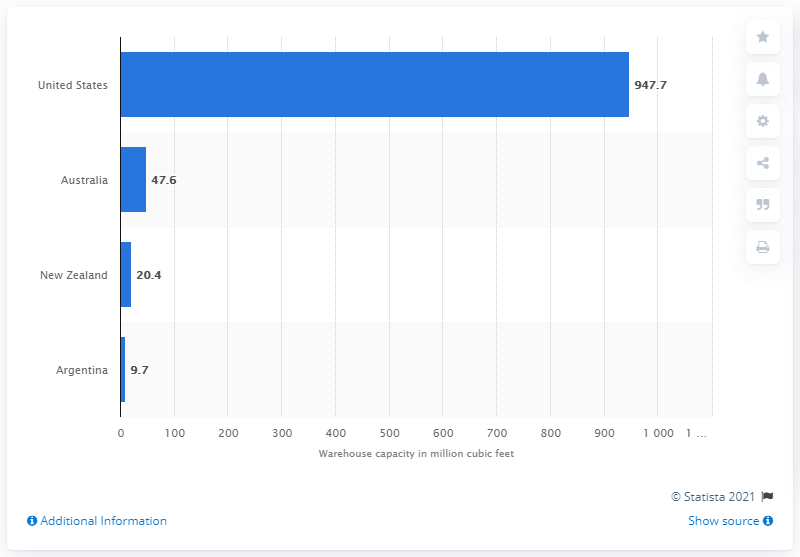Draw attention to some important aspects in this diagram. In 2019, Americold Logistics had approximately 947.7 cubic feet of storage space. 